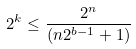<formula> <loc_0><loc_0><loc_500><loc_500>2 ^ { k } \leq \frac { 2 ^ { n } } { ( n 2 ^ { b - 1 } + 1 ) }</formula> 